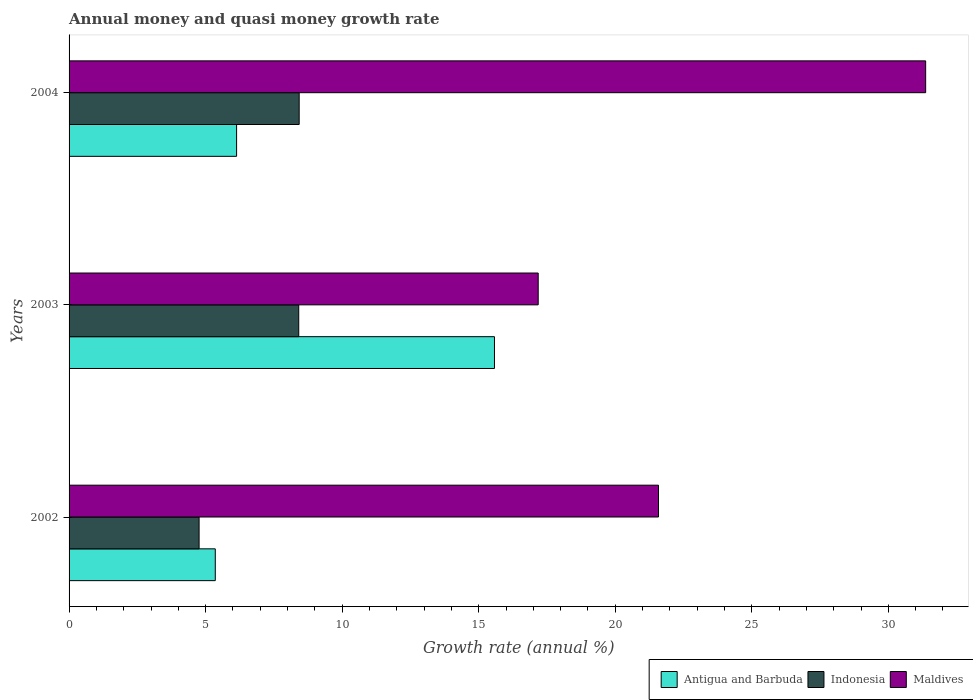Are the number of bars per tick equal to the number of legend labels?
Your response must be concise. Yes. What is the label of the 2nd group of bars from the top?
Keep it short and to the point. 2003. What is the growth rate in Indonesia in 2004?
Provide a succinct answer. 8.43. Across all years, what is the maximum growth rate in Antigua and Barbuda?
Your response must be concise. 15.58. Across all years, what is the minimum growth rate in Indonesia?
Ensure brevity in your answer.  4.76. In which year was the growth rate in Antigua and Barbuda maximum?
Provide a short and direct response. 2003. In which year was the growth rate in Maldives minimum?
Give a very brief answer. 2003. What is the total growth rate in Antigua and Barbuda in the graph?
Offer a terse response. 27.07. What is the difference between the growth rate in Indonesia in 2003 and that in 2004?
Offer a terse response. -0.02. What is the difference between the growth rate in Maldives in 2003 and the growth rate in Indonesia in 2002?
Your answer should be compact. 12.42. What is the average growth rate in Maldives per year?
Make the answer very short. 23.38. In the year 2002, what is the difference between the growth rate in Indonesia and growth rate in Maldives?
Your answer should be compact. -16.82. In how many years, is the growth rate in Antigua and Barbuda greater than 6 %?
Keep it short and to the point. 2. What is the ratio of the growth rate in Maldives in 2002 to that in 2003?
Your response must be concise. 1.26. What is the difference between the highest and the second highest growth rate in Indonesia?
Your answer should be compact. 0.02. What is the difference between the highest and the lowest growth rate in Maldives?
Your answer should be compact. 14.19. In how many years, is the growth rate in Maldives greater than the average growth rate in Maldives taken over all years?
Make the answer very short. 1. Is the sum of the growth rate in Maldives in 2002 and 2004 greater than the maximum growth rate in Antigua and Barbuda across all years?
Your answer should be very brief. Yes. What does the 1st bar from the top in 2003 represents?
Your answer should be very brief. Maldives. What does the 3rd bar from the bottom in 2002 represents?
Provide a succinct answer. Maldives. Is it the case that in every year, the sum of the growth rate in Maldives and growth rate in Indonesia is greater than the growth rate in Antigua and Barbuda?
Give a very brief answer. Yes. Are all the bars in the graph horizontal?
Provide a short and direct response. Yes. What is the difference between two consecutive major ticks on the X-axis?
Provide a succinct answer. 5. Are the values on the major ticks of X-axis written in scientific E-notation?
Offer a very short reply. No. How are the legend labels stacked?
Offer a terse response. Horizontal. What is the title of the graph?
Offer a very short reply. Annual money and quasi money growth rate. Does "Guam" appear as one of the legend labels in the graph?
Provide a succinct answer. No. What is the label or title of the X-axis?
Offer a terse response. Growth rate (annual %). What is the label or title of the Y-axis?
Your answer should be very brief. Years. What is the Growth rate (annual %) in Antigua and Barbuda in 2002?
Your answer should be very brief. 5.35. What is the Growth rate (annual %) in Indonesia in 2002?
Your response must be concise. 4.76. What is the Growth rate (annual %) of Maldives in 2002?
Your response must be concise. 21.58. What is the Growth rate (annual %) of Antigua and Barbuda in 2003?
Offer a terse response. 15.58. What is the Growth rate (annual %) of Indonesia in 2003?
Ensure brevity in your answer.  8.41. What is the Growth rate (annual %) of Maldives in 2003?
Your response must be concise. 17.18. What is the Growth rate (annual %) in Antigua and Barbuda in 2004?
Offer a very short reply. 6.13. What is the Growth rate (annual %) in Indonesia in 2004?
Make the answer very short. 8.43. What is the Growth rate (annual %) in Maldives in 2004?
Offer a terse response. 31.37. Across all years, what is the maximum Growth rate (annual %) in Antigua and Barbuda?
Make the answer very short. 15.58. Across all years, what is the maximum Growth rate (annual %) in Indonesia?
Give a very brief answer. 8.43. Across all years, what is the maximum Growth rate (annual %) of Maldives?
Provide a short and direct response. 31.37. Across all years, what is the minimum Growth rate (annual %) of Antigua and Barbuda?
Your answer should be compact. 5.35. Across all years, what is the minimum Growth rate (annual %) of Indonesia?
Offer a terse response. 4.76. Across all years, what is the minimum Growth rate (annual %) in Maldives?
Keep it short and to the point. 17.18. What is the total Growth rate (annual %) in Antigua and Barbuda in the graph?
Offer a terse response. 27.07. What is the total Growth rate (annual %) of Indonesia in the graph?
Provide a succinct answer. 21.6. What is the total Growth rate (annual %) of Maldives in the graph?
Offer a terse response. 70.13. What is the difference between the Growth rate (annual %) of Antigua and Barbuda in 2002 and that in 2003?
Give a very brief answer. -10.22. What is the difference between the Growth rate (annual %) of Indonesia in 2002 and that in 2003?
Offer a very short reply. -3.65. What is the difference between the Growth rate (annual %) of Maldives in 2002 and that in 2003?
Provide a short and direct response. 4.41. What is the difference between the Growth rate (annual %) of Antigua and Barbuda in 2002 and that in 2004?
Make the answer very short. -0.78. What is the difference between the Growth rate (annual %) in Indonesia in 2002 and that in 2004?
Give a very brief answer. -3.66. What is the difference between the Growth rate (annual %) in Maldives in 2002 and that in 2004?
Keep it short and to the point. -9.78. What is the difference between the Growth rate (annual %) in Antigua and Barbuda in 2003 and that in 2004?
Give a very brief answer. 9.44. What is the difference between the Growth rate (annual %) of Indonesia in 2003 and that in 2004?
Your answer should be compact. -0.02. What is the difference between the Growth rate (annual %) in Maldives in 2003 and that in 2004?
Keep it short and to the point. -14.19. What is the difference between the Growth rate (annual %) in Antigua and Barbuda in 2002 and the Growth rate (annual %) in Indonesia in 2003?
Provide a short and direct response. -3.06. What is the difference between the Growth rate (annual %) of Antigua and Barbuda in 2002 and the Growth rate (annual %) of Maldives in 2003?
Offer a very short reply. -11.83. What is the difference between the Growth rate (annual %) of Indonesia in 2002 and the Growth rate (annual %) of Maldives in 2003?
Make the answer very short. -12.42. What is the difference between the Growth rate (annual %) of Antigua and Barbuda in 2002 and the Growth rate (annual %) of Indonesia in 2004?
Provide a succinct answer. -3.07. What is the difference between the Growth rate (annual %) of Antigua and Barbuda in 2002 and the Growth rate (annual %) of Maldives in 2004?
Provide a short and direct response. -26.01. What is the difference between the Growth rate (annual %) of Indonesia in 2002 and the Growth rate (annual %) of Maldives in 2004?
Your answer should be very brief. -26.61. What is the difference between the Growth rate (annual %) of Antigua and Barbuda in 2003 and the Growth rate (annual %) of Indonesia in 2004?
Provide a succinct answer. 7.15. What is the difference between the Growth rate (annual %) in Antigua and Barbuda in 2003 and the Growth rate (annual %) in Maldives in 2004?
Offer a very short reply. -15.79. What is the difference between the Growth rate (annual %) in Indonesia in 2003 and the Growth rate (annual %) in Maldives in 2004?
Give a very brief answer. -22.96. What is the average Growth rate (annual %) in Antigua and Barbuda per year?
Make the answer very short. 9.02. What is the average Growth rate (annual %) of Indonesia per year?
Offer a very short reply. 7.2. What is the average Growth rate (annual %) of Maldives per year?
Your answer should be very brief. 23.38. In the year 2002, what is the difference between the Growth rate (annual %) of Antigua and Barbuda and Growth rate (annual %) of Indonesia?
Your answer should be compact. 0.59. In the year 2002, what is the difference between the Growth rate (annual %) in Antigua and Barbuda and Growth rate (annual %) in Maldives?
Provide a succinct answer. -16.23. In the year 2002, what is the difference between the Growth rate (annual %) of Indonesia and Growth rate (annual %) of Maldives?
Offer a terse response. -16.82. In the year 2003, what is the difference between the Growth rate (annual %) in Antigua and Barbuda and Growth rate (annual %) in Indonesia?
Provide a short and direct response. 7.17. In the year 2003, what is the difference between the Growth rate (annual %) of Antigua and Barbuda and Growth rate (annual %) of Maldives?
Your response must be concise. -1.6. In the year 2003, what is the difference between the Growth rate (annual %) of Indonesia and Growth rate (annual %) of Maldives?
Offer a terse response. -8.77. In the year 2004, what is the difference between the Growth rate (annual %) of Antigua and Barbuda and Growth rate (annual %) of Indonesia?
Your answer should be compact. -2.29. In the year 2004, what is the difference between the Growth rate (annual %) in Antigua and Barbuda and Growth rate (annual %) in Maldives?
Your response must be concise. -25.23. In the year 2004, what is the difference between the Growth rate (annual %) of Indonesia and Growth rate (annual %) of Maldives?
Make the answer very short. -22.94. What is the ratio of the Growth rate (annual %) in Antigua and Barbuda in 2002 to that in 2003?
Provide a succinct answer. 0.34. What is the ratio of the Growth rate (annual %) of Indonesia in 2002 to that in 2003?
Offer a very short reply. 0.57. What is the ratio of the Growth rate (annual %) of Maldives in 2002 to that in 2003?
Your response must be concise. 1.26. What is the ratio of the Growth rate (annual %) in Antigua and Barbuda in 2002 to that in 2004?
Provide a short and direct response. 0.87. What is the ratio of the Growth rate (annual %) in Indonesia in 2002 to that in 2004?
Your answer should be very brief. 0.57. What is the ratio of the Growth rate (annual %) in Maldives in 2002 to that in 2004?
Provide a short and direct response. 0.69. What is the ratio of the Growth rate (annual %) of Antigua and Barbuda in 2003 to that in 2004?
Your answer should be compact. 2.54. What is the ratio of the Growth rate (annual %) of Maldives in 2003 to that in 2004?
Provide a short and direct response. 0.55. What is the difference between the highest and the second highest Growth rate (annual %) of Antigua and Barbuda?
Give a very brief answer. 9.44. What is the difference between the highest and the second highest Growth rate (annual %) of Indonesia?
Give a very brief answer. 0.02. What is the difference between the highest and the second highest Growth rate (annual %) in Maldives?
Provide a succinct answer. 9.78. What is the difference between the highest and the lowest Growth rate (annual %) in Antigua and Barbuda?
Keep it short and to the point. 10.22. What is the difference between the highest and the lowest Growth rate (annual %) in Indonesia?
Your response must be concise. 3.66. What is the difference between the highest and the lowest Growth rate (annual %) of Maldives?
Offer a very short reply. 14.19. 